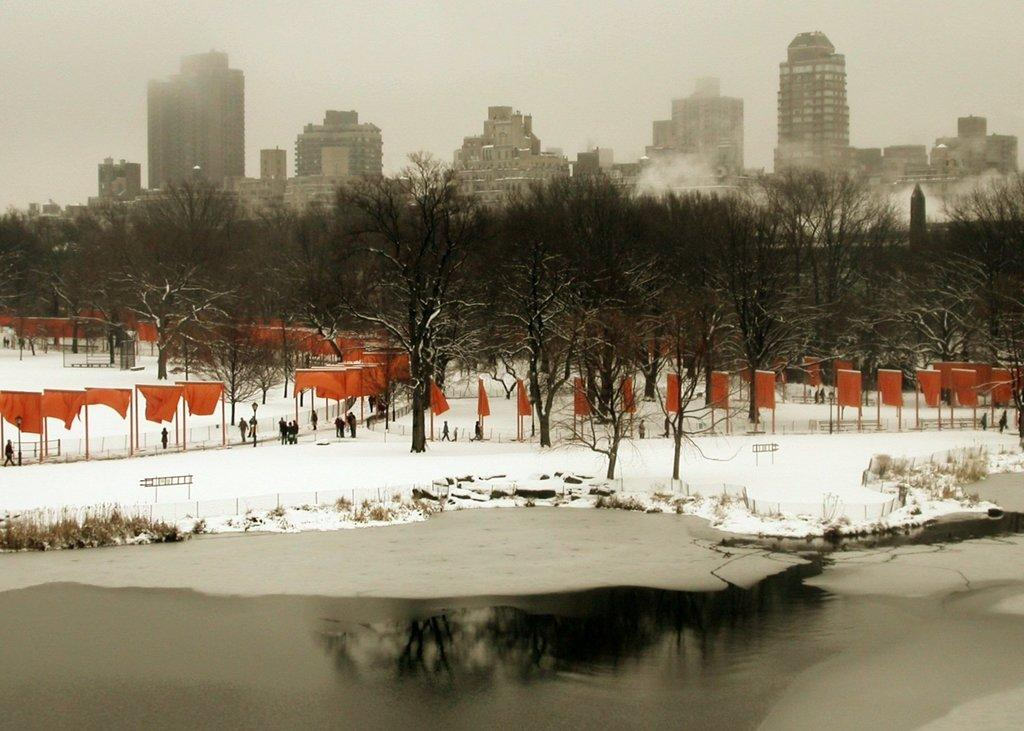What is one of the natural elements present in the image? There is water in the image. What is another natural element present in the image? There is snow in the image. What type of vegetation can be seen in the image? There are trees in the image. What man-made objects are present in the image? There are flags in the image. Are there any human subjects in the image? Yes, there are people in the image. What can be seen in the background of the image? There are buildings in the background of the image. What type of rifle can be seen in the hands of the people in the image? There are no rifles present in the image; people are not holding any weapons. How many cows can be seen grazing in the background of the image? There are no cows present in the image; the background features buildings, not animals. 